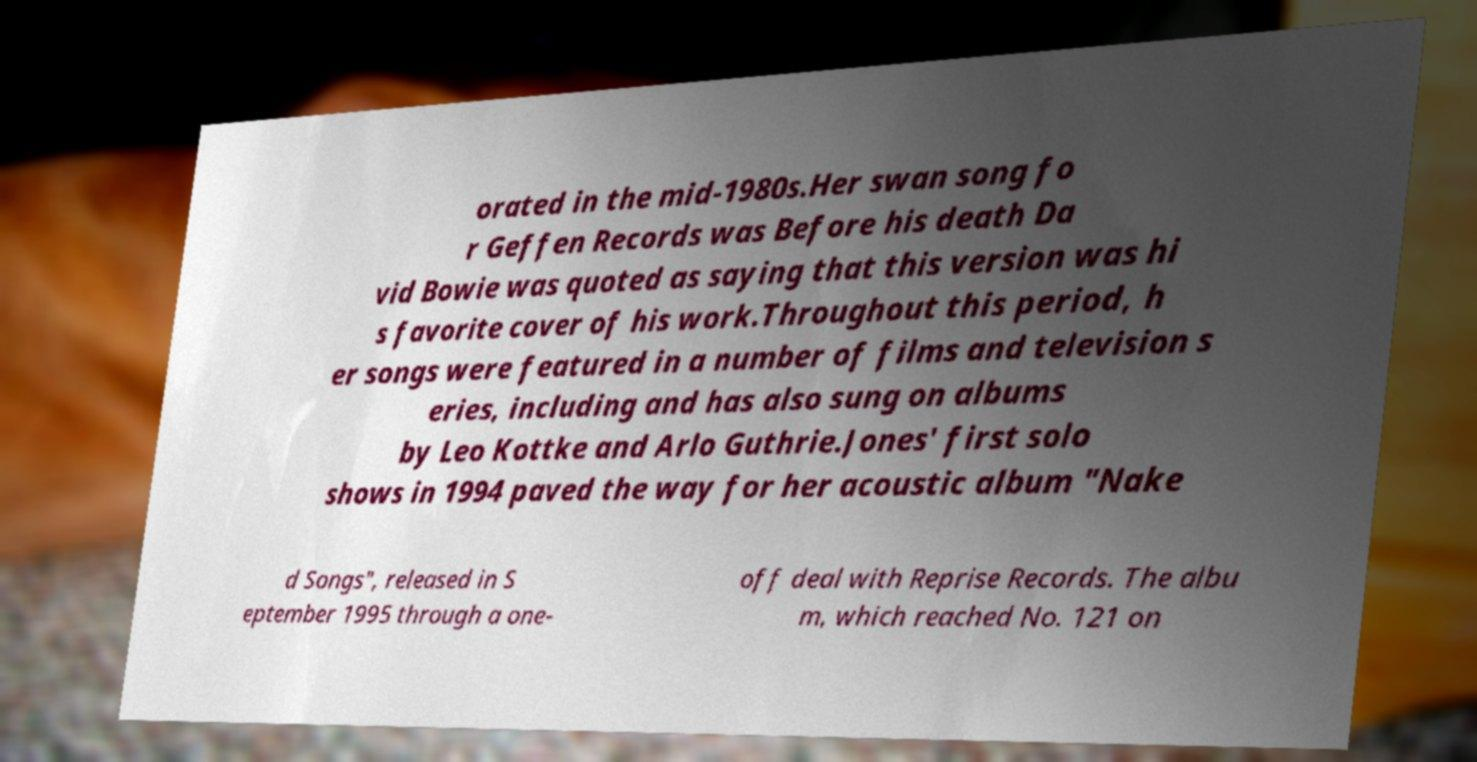I need the written content from this picture converted into text. Can you do that? orated in the mid-1980s.Her swan song fo r Geffen Records was Before his death Da vid Bowie was quoted as saying that this version was hi s favorite cover of his work.Throughout this period, h er songs were featured in a number of films and television s eries, including and has also sung on albums by Leo Kottke and Arlo Guthrie.Jones' first solo shows in 1994 paved the way for her acoustic album "Nake d Songs", released in S eptember 1995 through a one- off deal with Reprise Records. The albu m, which reached No. 121 on 